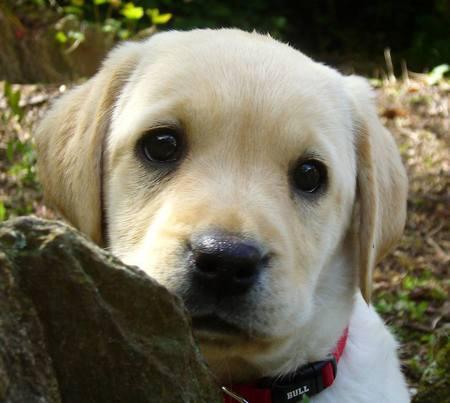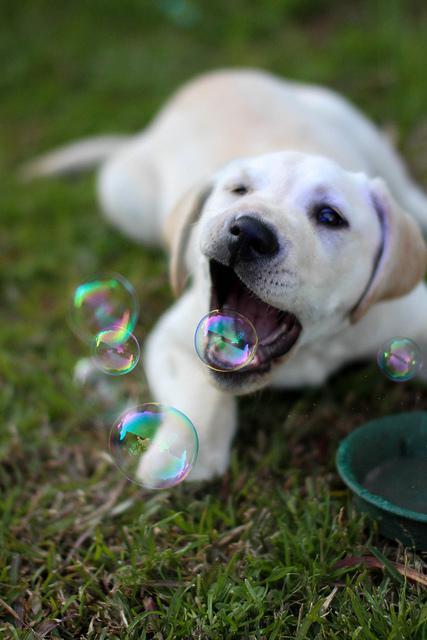The first image is the image on the left, the second image is the image on the right. Assess this claim about the two images: "Two little dogs are shown, one with a toy.". Correct or not? Answer yes or no. No. The first image is the image on the left, the second image is the image on the right. Examine the images to the left and right. Is the description "Right image shows a pale puppy with some kind of play-thing." accurate? Answer yes or no. Yes. 